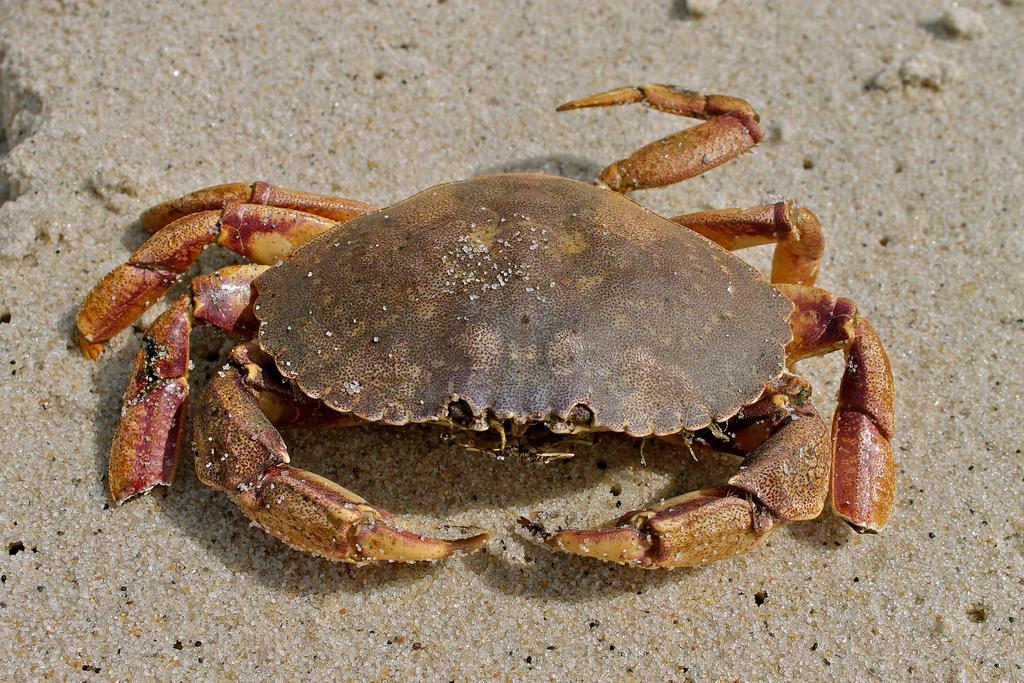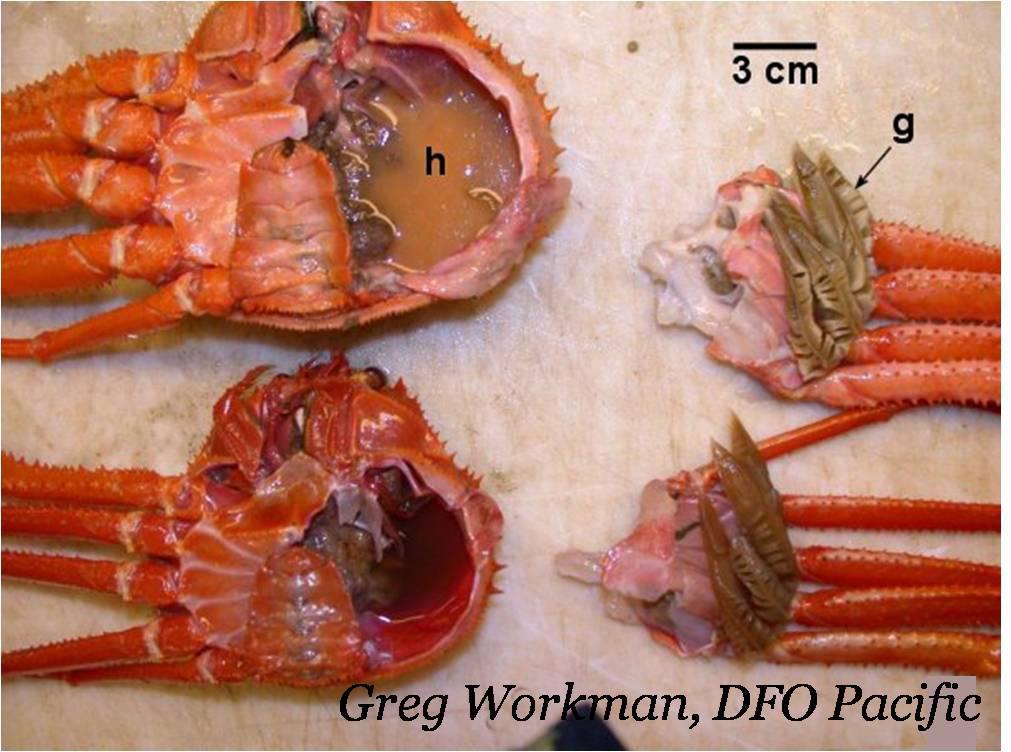The first image is the image on the left, the second image is the image on the right. Given the left and right images, does the statement "All of the crabs in the images are still whole." hold true? Answer yes or no. No. The first image is the image on the left, the second image is the image on the right. Assess this claim about the two images: "The left image contains two crabs.". Correct or not? Answer yes or no. No. 